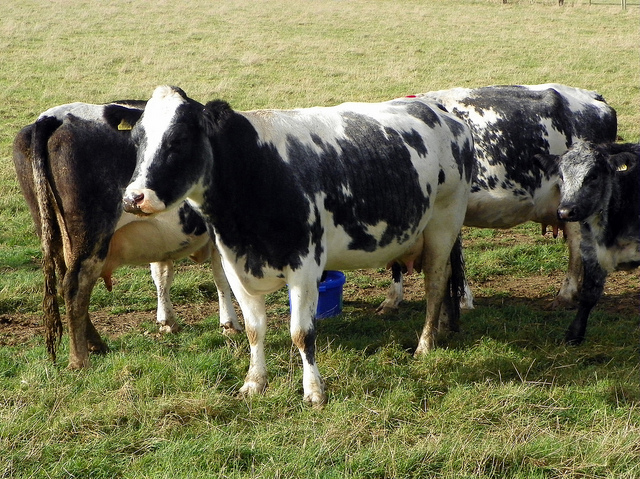How many cows are there? There are four cows in the image, peacefully grazing in what appears to be a lush green pasture. The cows have distinctive black and white markings typical of certain dairy breeds, suggesting they might be used for milk production. 